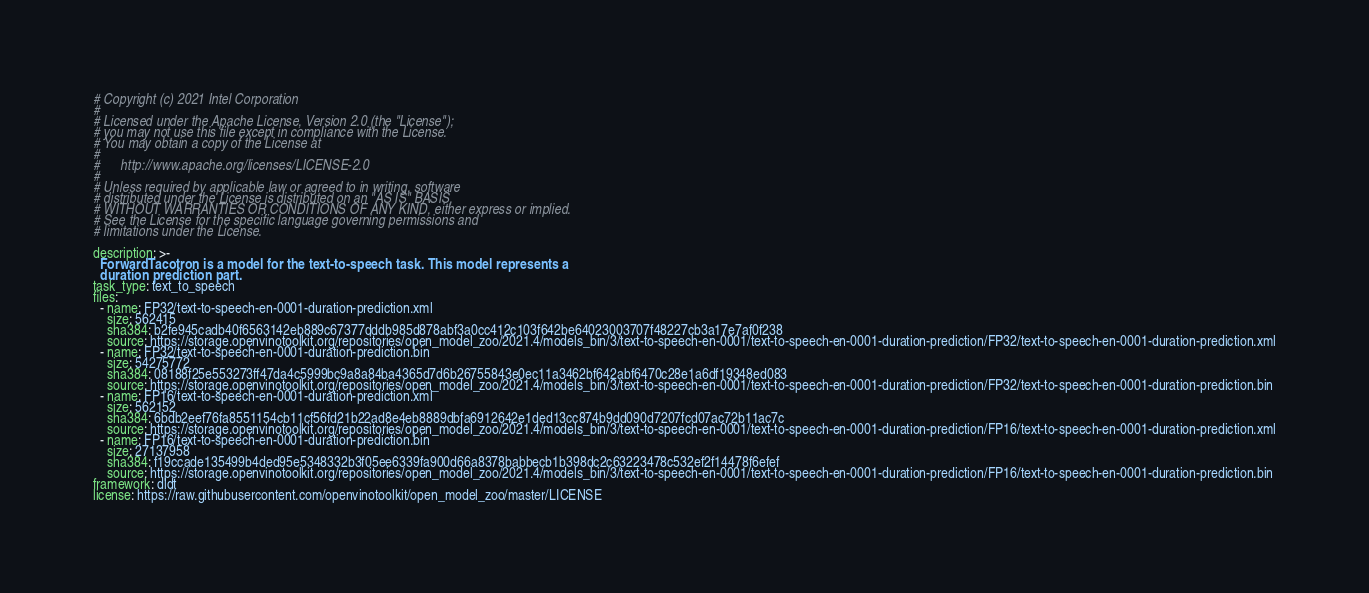Convert code to text. <code><loc_0><loc_0><loc_500><loc_500><_YAML_># Copyright (c) 2021 Intel Corporation
#
# Licensed under the Apache License, Version 2.0 (the "License");
# you may not use this file except in compliance with the License.
# You may obtain a copy of the License at
#
#      http://www.apache.org/licenses/LICENSE-2.0
#
# Unless required by applicable law or agreed to in writing, software
# distributed under the License is distributed on an "AS IS" BASIS,
# WITHOUT WARRANTIES OR CONDITIONS OF ANY KIND, either express or implied.
# See the License for the specific language governing permissions and
# limitations under the License.

description: >-
  ForwardTacotron is a model for the text-to-speech task. This model represents a
  duration prediction part.
task_type: text_to_speech
files:
  - name: FP32/text-to-speech-en-0001-duration-prediction.xml
    size: 562415
    sha384: b2fe945cadb40f6563142eb889c67377dddb985d878abf3a0cc412c103f642be64023003707f48227cb3a17e7af0f238
    source: https://storage.openvinotoolkit.org/repositories/open_model_zoo/2021.4/models_bin/3/text-to-speech-en-0001/text-to-speech-en-0001-duration-prediction/FP32/text-to-speech-en-0001-duration-prediction.xml
  - name: FP32/text-to-speech-en-0001-duration-prediction.bin
    size: 54275772
    sha384: 08188f25e553273ff47da4c5999bc9a8a84ba4365d7d6b26755843e0ec11a3462bf642abf6470c28e1a6df19348ed083
    source: https://storage.openvinotoolkit.org/repositories/open_model_zoo/2021.4/models_bin/3/text-to-speech-en-0001/text-to-speech-en-0001-duration-prediction/FP32/text-to-speech-en-0001-duration-prediction.bin
  - name: FP16/text-to-speech-en-0001-duration-prediction.xml
    size: 562152
    sha384: 6bdb2eef76fa8551154cb11cf56fd21b22ad8e4eb8889dbfa6912642e1ded13cc874b9dd090d7207fcd07ac72b11ac7c
    source: https://storage.openvinotoolkit.org/repositories/open_model_zoo/2021.4/models_bin/3/text-to-speech-en-0001/text-to-speech-en-0001-duration-prediction/FP16/text-to-speech-en-0001-duration-prediction.xml
  - name: FP16/text-to-speech-en-0001-duration-prediction.bin
    size: 27137958
    sha384: f19ccade135499b4ded95e5348332b3f05ee6339fa900d66a8378babbecb1b398dc2c63223478c532ef2f14478f6efef
    source: https://storage.openvinotoolkit.org/repositories/open_model_zoo/2021.4/models_bin/3/text-to-speech-en-0001/text-to-speech-en-0001-duration-prediction/FP16/text-to-speech-en-0001-duration-prediction.bin
framework: dldt
license: https://raw.githubusercontent.com/openvinotoolkit/open_model_zoo/master/LICENSE
</code> 